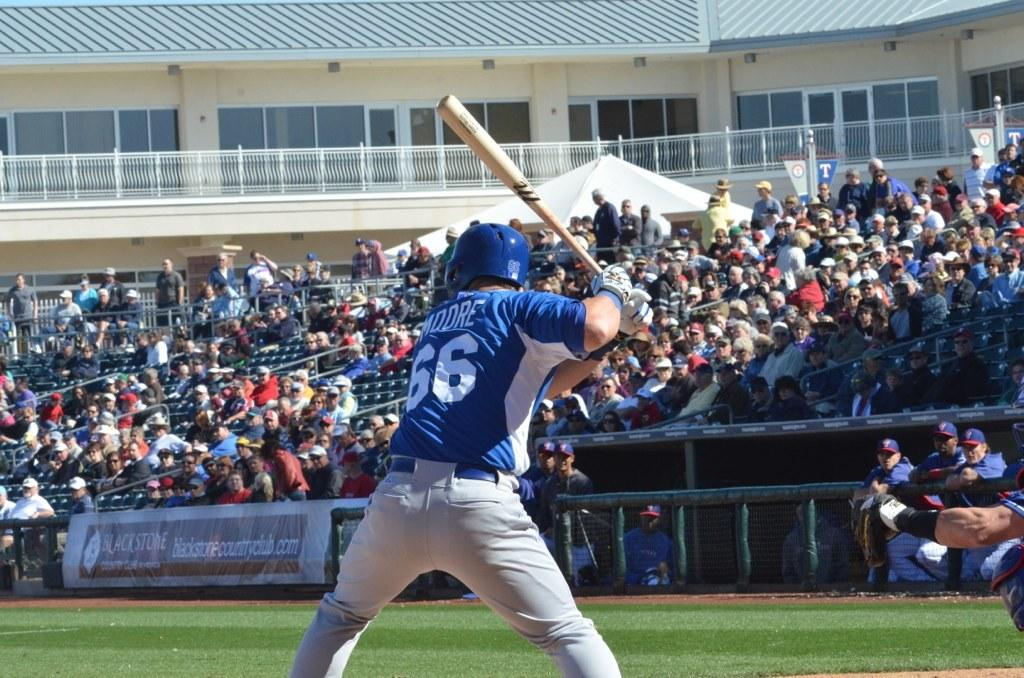<image>
Create a compact narrative representing the image presented. a baseball player in a blue 66 jersey up to bat 